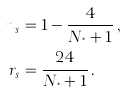Convert formula to latex. <formula><loc_0><loc_0><loc_500><loc_500>n _ { s } & = 1 - \frac { 4 } { N _ { ^ { * } } + 1 } \, , \\ r _ { s } & = \frac { 2 4 } { N _ { ^ { * } } + 1 } \, .</formula> 